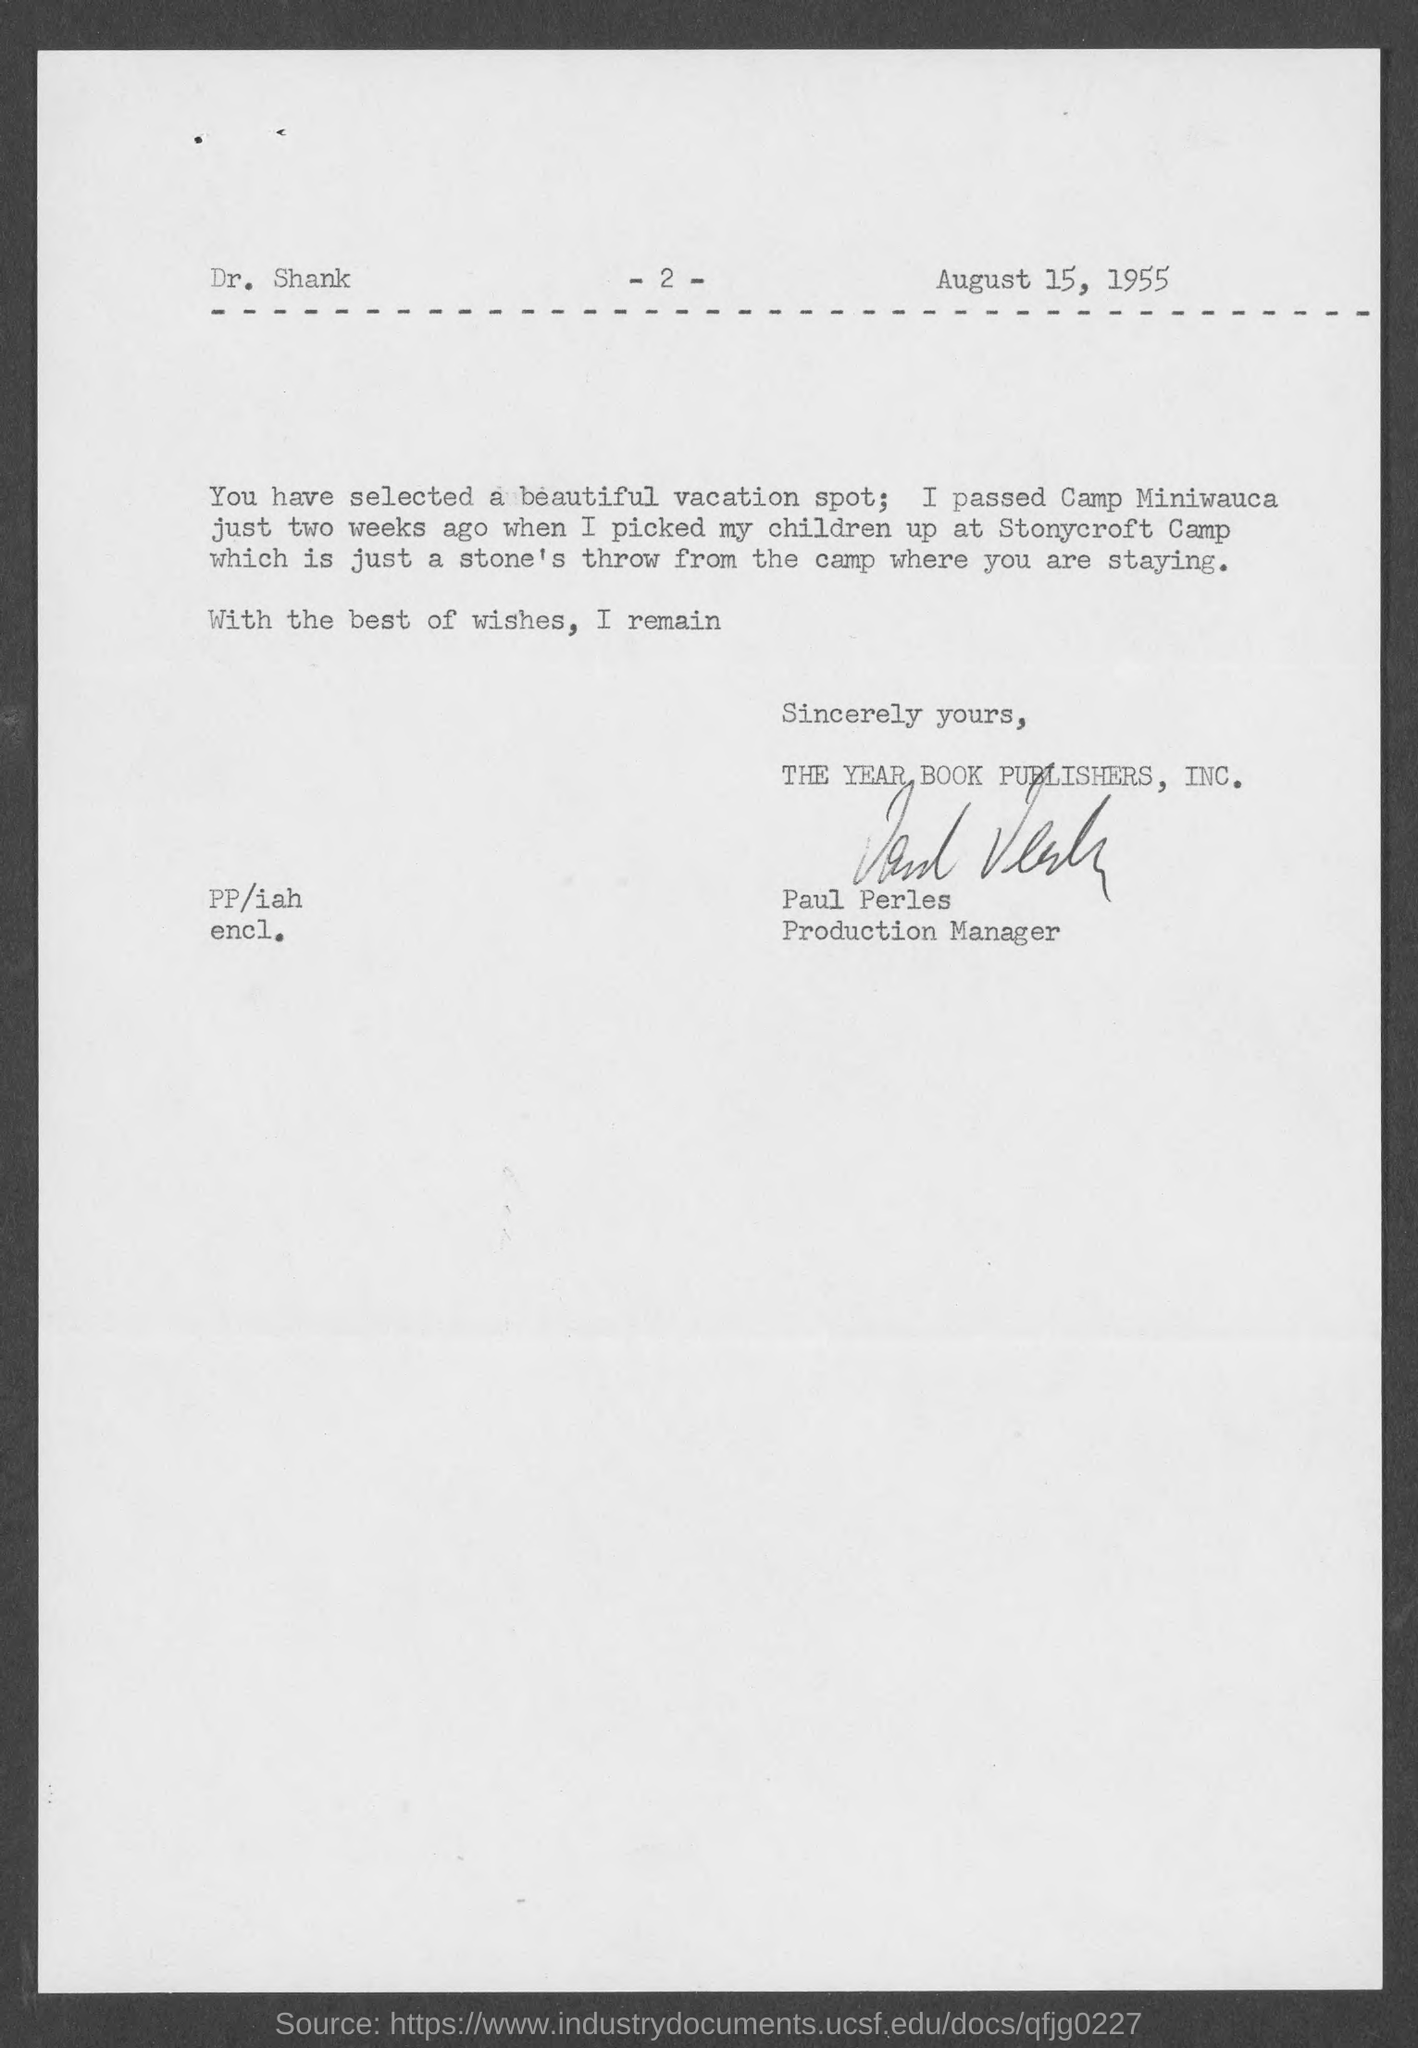What is the date on the document?
Keep it short and to the point. August 15, 1955. To Whom is this letter addressed to?
Ensure brevity in your answer.  Dr. Shank. Who is this letter from?
Provide a short and direct response. Paul Perles. Where did he pass two weeks ago?
Make the answer very short. Camp Miniwauca. 